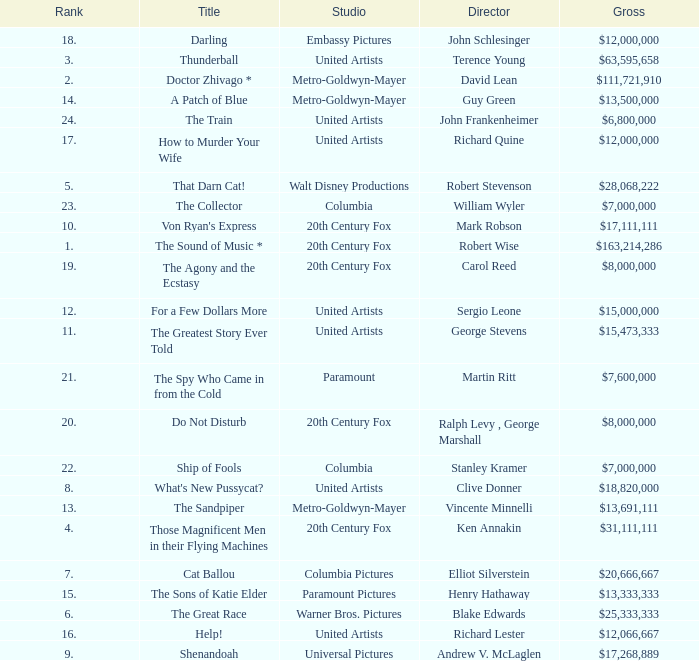What is Studio, when Title is "Do Not Disturb"? 20th Century Fox. 